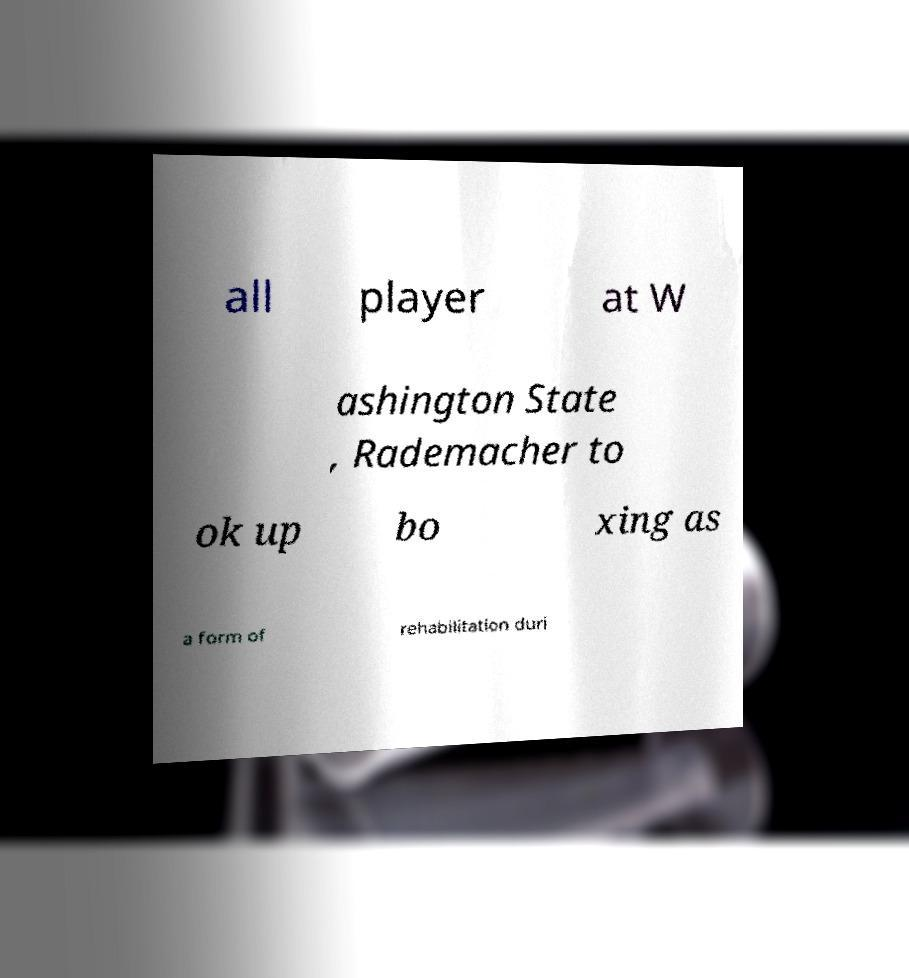Please read and relay the text visible in this image. What does it say? all player at W ashington State , Rademacher to ok up bo xing as a form of rehabilitation duri 